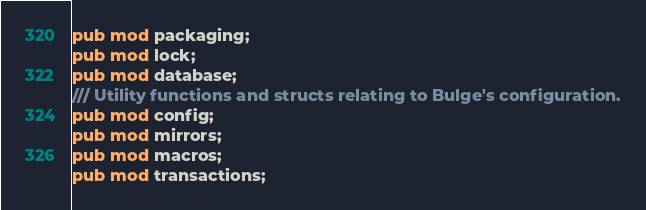Convert code to text. <code><loc_0><loc_0><loc_500><loc_500><_Rust_>pub mod packaging;
pub mod lock;
pub mod database;
/// Utility functions and structs relating to Bulge's configuration.
pub mod config;
pub mod mirrors;
pub mod macros;
pub mod transactions;</code> 